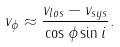Convert formula to latex. <formula><loc_0><loc_0><loc_500><loc_500>v _ { \phi } \approx \frac { v _ { l o s } - v _ { s y s } } { \cos \phi \sin i } .</formula> 